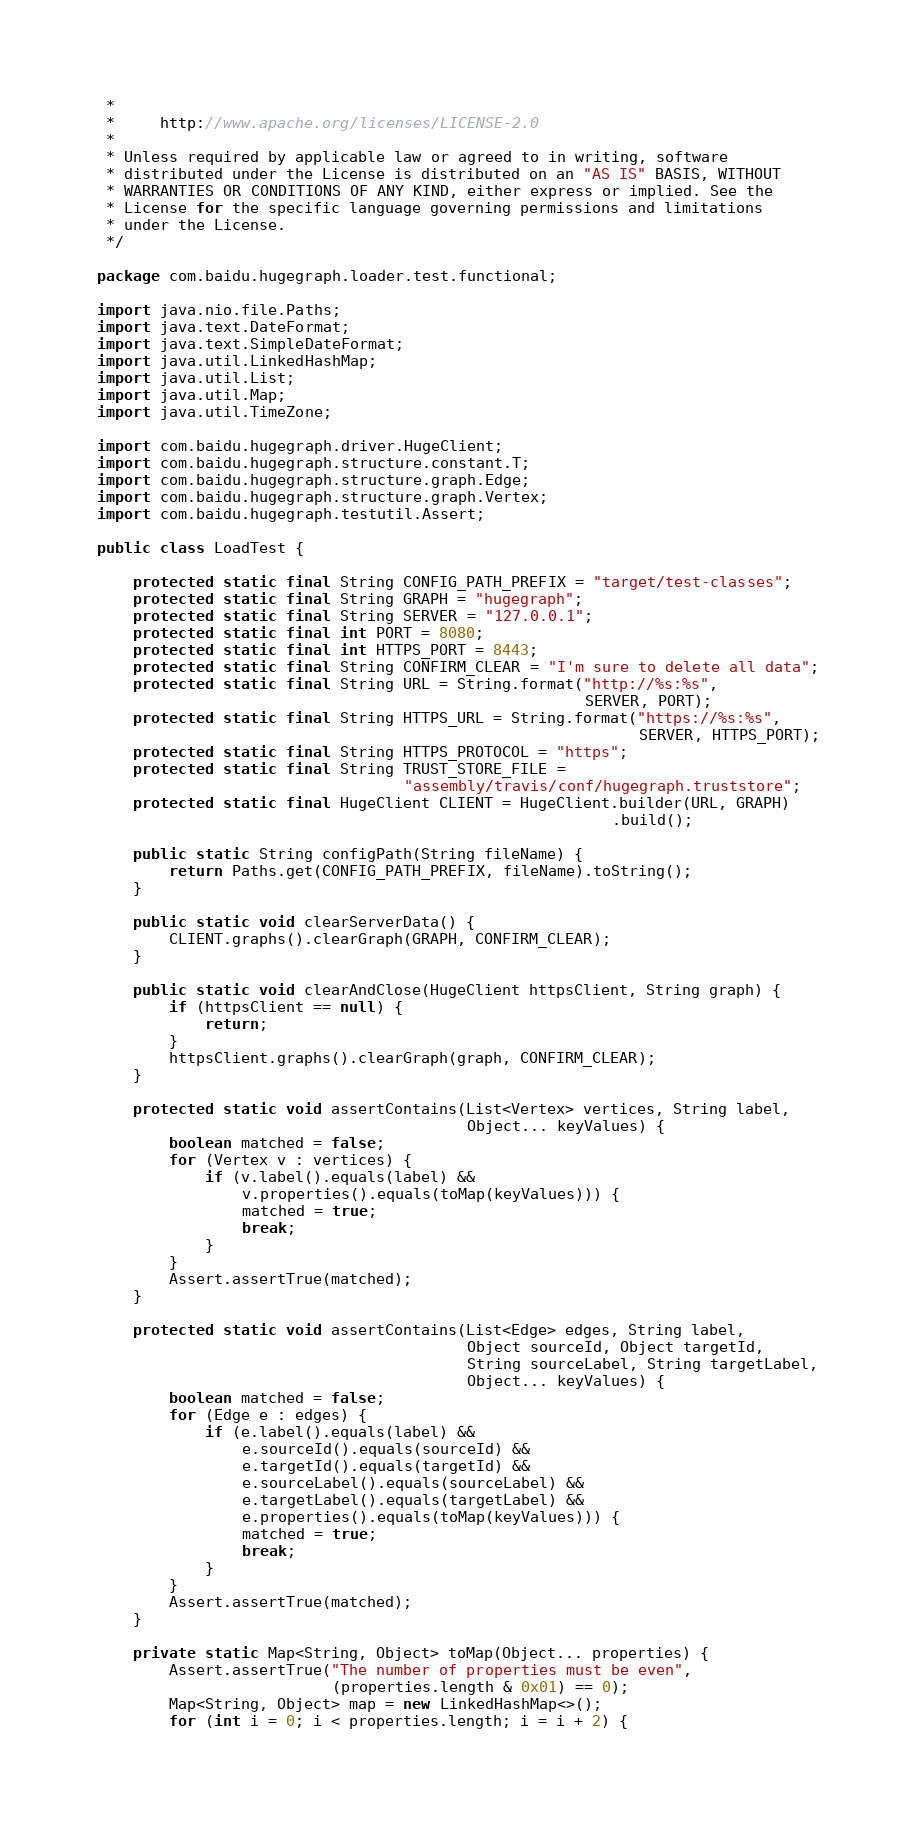Convert code to text. <code><loc_0><loc_0><loc_500><loc_500><_Java_> *
 *     http://www.apache.org/licenses/LICENSE-2.0
 *
 * Unless required by applicable law or agreed to in writing, software
 * distributed under the License is distributed on an "AS IS" BASIS, WITHOUT
 * WARRANTIES OR CONDITIONS OF ANY KIND, either express or implied. See the
 * License for the specific language governing permissions and limitations
 * under the License.
 */

package com.baidu.hugegraph.loader.test.functional;

import java.nio.file.Paths;
import java.text.DateFormat;
import java.text.SimpleDateFormat;
import java.util.LinkedHashMap;
import java.util.List;
import java.util.Map;
import java.util.TimeZone;

import com.baidu.hugegraph.driver.HugeClient;
import com.baidu.hugegraph.structure.constant.T;
import com.baidu.hugegraph.structure.graph.Edge;
import com.baidu.hugegraph.structure.graph.Vertex;
import com.baidu.hugegraph.testutil.Assert;

public class LoadTest {

    protected static final String CONFIG_PATH_PREFIX = "target/test-classes";
    protected static final String GRAPH = "hugegraph";
    protected static final String SERVER = "127.0.0.1";
    protected static final int PORT = 8080;
    protected static final int HTTPS_PORT = 8443;
    protected static final String CONFIRM_CLEAR = "I'm sure to delete all data";
    protected static final String URL = String.format("http://%s:%s",
                                                      SERVER, PORT);
    protected static final String HTTPS_URL = String.format("https://%s:%s",
                                                            SERVER, HTTPS_PORT);
    protected static final String HTTPS_PROTOCOL = "https";
    protected static final String TRUST_STORE_FILE =
                                  "assembly/travis/conf/hugegraph.truststore";
    protected static final HugeClient CLIENT = HugeClient.builder(URL, GRAPH)
                                                         .build();

    public static String configPath(String fileName) {
        return Paths.get(CONFIG_PATH_PREFIX, fileName).toString();
    }

    public static void clearServerData() {
        CLIENT.graphs().clearGraph(GRAPH, CONFIRM_CLEAR);
    }

    public static void clearAndClose(HugeClient httpsClient, String graph) {
        if (httpsClient == null) {
            return;
        }
        httpsClient.graphs().clearGraph(graph, CONFIRM_CLEAR);
    }

    protected static void assertContains(List<Vertex> vertices, String label,
                                         Object... keyValues) {
        boolean matched = false;
        for (Vertex v : vertices) {
            if (v.label().equals(label) &&
                v.properties().equals(toMap(keyValues))) {
                matched = true;
                break;
            }
        }
        Assert.assertTrue(matched);
    }

    protected static void assertContains(List<Edge> edges, String label,
                                         Object sourceId, Object targetId,
                                         String sourceLabel, String targetLabel,
                                         Object... keyValues) {
        boolean matched = false;
        for (Edge e : edges) {
            if (e.label().equals(label) &&
                e.sourceId().equals(sourceId) &&
                e.targetId().equals(targetId) &&
                e.sourceLabel().equals(sourceLabel) &&
                e.targetLabel().equals(targetLabel) &&
                e.properties().equals(toMap(keyValues))) {
                matched = true;
                break;
            }
        }
        Assert.assertTrue(matched);
    }

    private static Map<String, Object> toMap(Object... properties) {
        Assert.assertTrue("The number of properties must be even",
                          (properties.length & 0x01) == 0);
        Map<String, Object> map = new LinkedHashMap<>();
        for (int i = 0; i < properties.length; i = i + 2) {</code> 